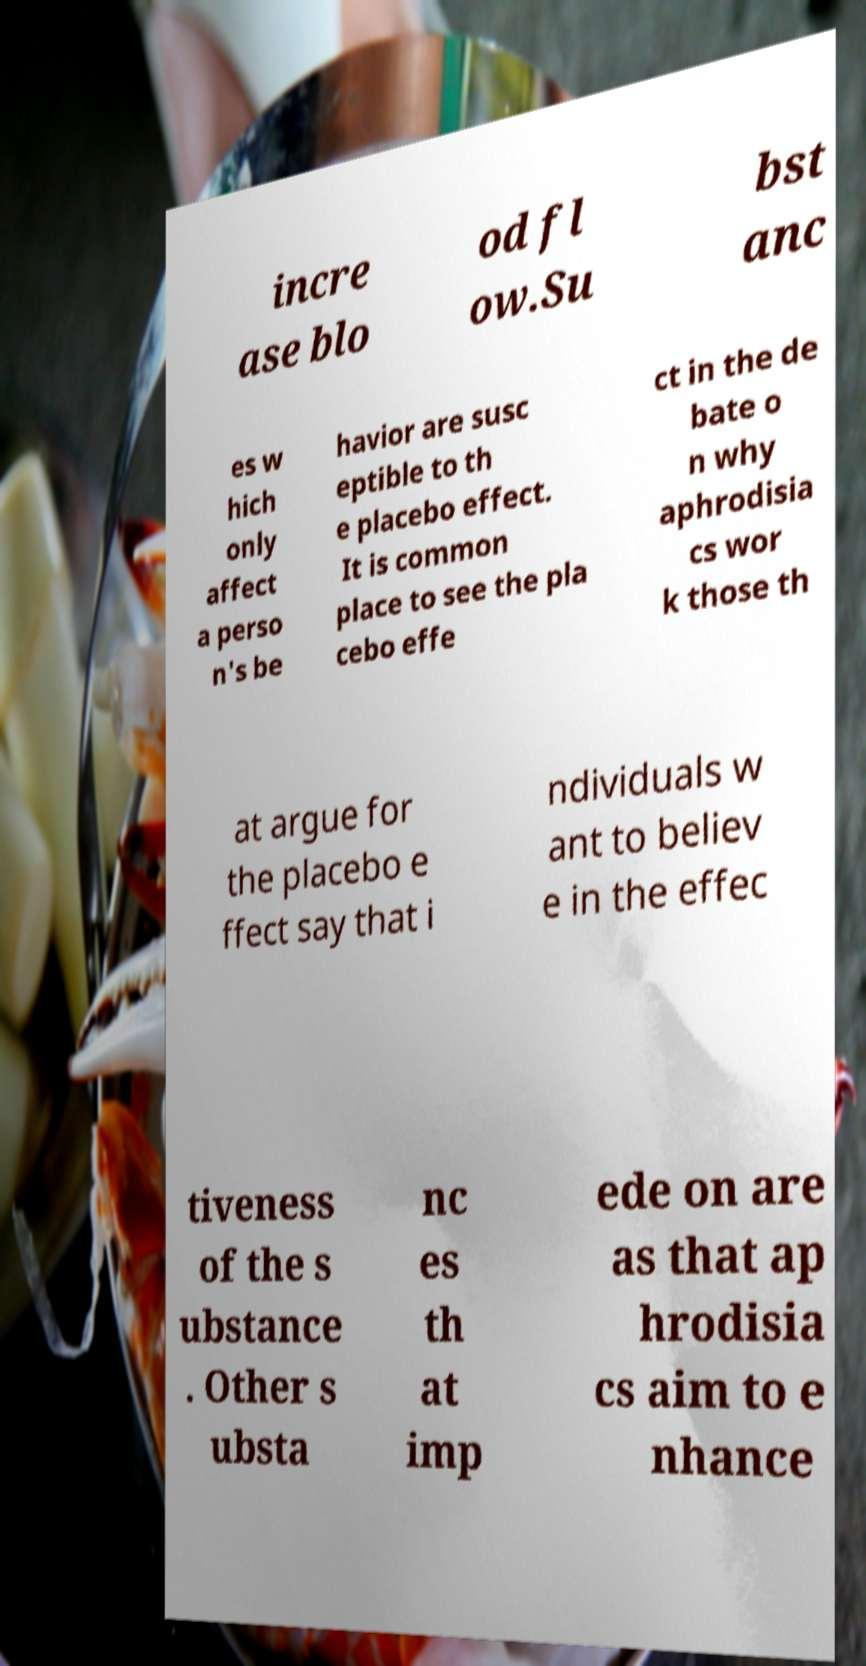Can you accurately transcribe the text from the provided image for me? incre ase blo od fl ow.Su bst anc es w hich only affect a perso n's be havior are susc eptible to th e placebo effect. It is common place to see the pla cebo effe ct in the de bate o n why aphrodisia cs wor k those th at argue for the placebo e ffect say that i ndividuals w ant to believ e in the effec tiveness of the s ubstance . Other s ubsta nc es th at imp ede on are as that ap hrodisia cs aim to e nhance 